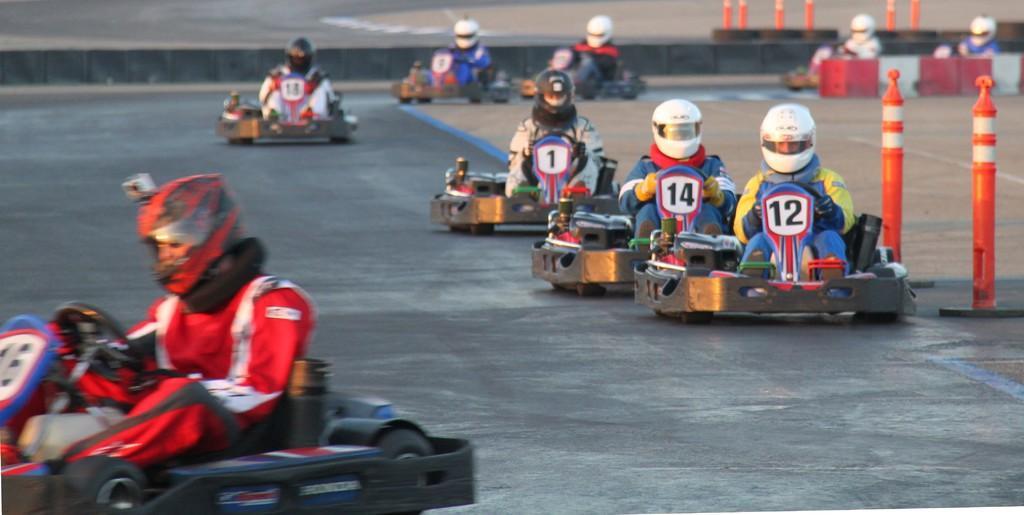Please provide a concise description of this image. In this picture we can see some persons riding go-kart and wearing helmet. On the right side of the image we can see poles, boxes. In the background of the image there is a road. 